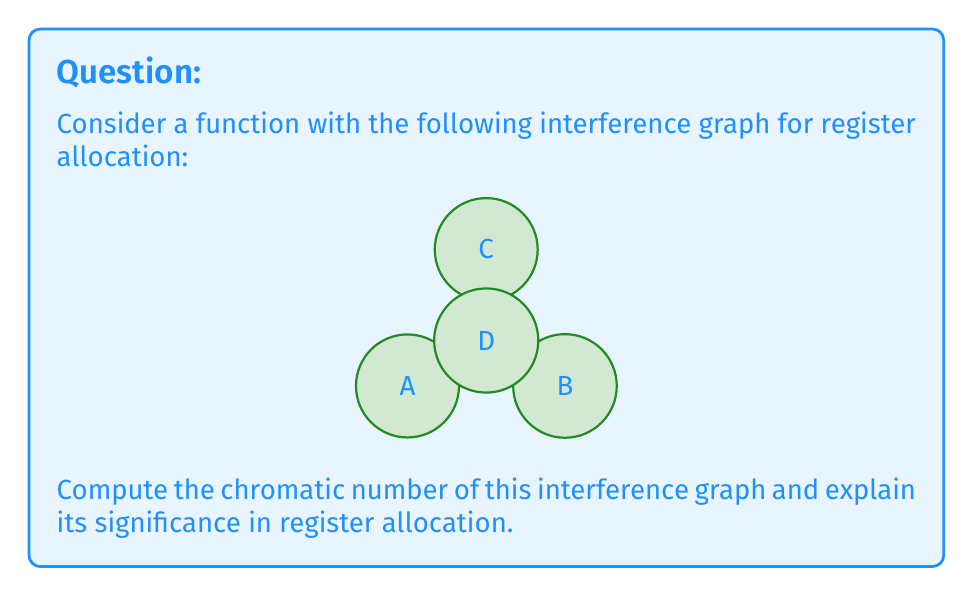Can you answer this question? To solve this problem, we need to follow these steps:

1) First, let's understand what the chromatic number represents in the context of register allocation:
   The chromatic number of an interference graph is the minimum number of colors needed to color the graph such that no two adjacent vertices have the same color. In register allocation, this number represents the minimum number of registers needed to store all variables without conflicts.

2) Now, let's analyze the given interference graph:
   - We have 4 vertices: A, B, C, and D
   - Each vertex is connected to every other vertex, forming a complete graph $K_4$

3) For a complete graph $K_n$, the chromatic number is always $n$, because each vertex needs a different color (or register in our case).

4) Therefore, the chromatic number of this graph is 4.

5) Significance in register allocation:
   - Each vertex in the graph represents a variable in the program
   - An edge between two vertices means those variables have overlapping lifetimes and cannot be assigned to the same register
   - The chromatic number 4 means we need at least 4 registers to allocate all variables without conflicts
   - If we have fewer than 4 registers available, some variables will need to be spilled to memory

6) In compiler design, this information is crucial for optimizing register allocation. If the target architecture has 4 or more registers, we can allocate all variables to registers. If not, the compiler needs to implement spilling strategies.
Answer: The chromatic number of the given interference graph is 4. This means that a minimum of 4 registers are required for optimal register allocation in this case. 